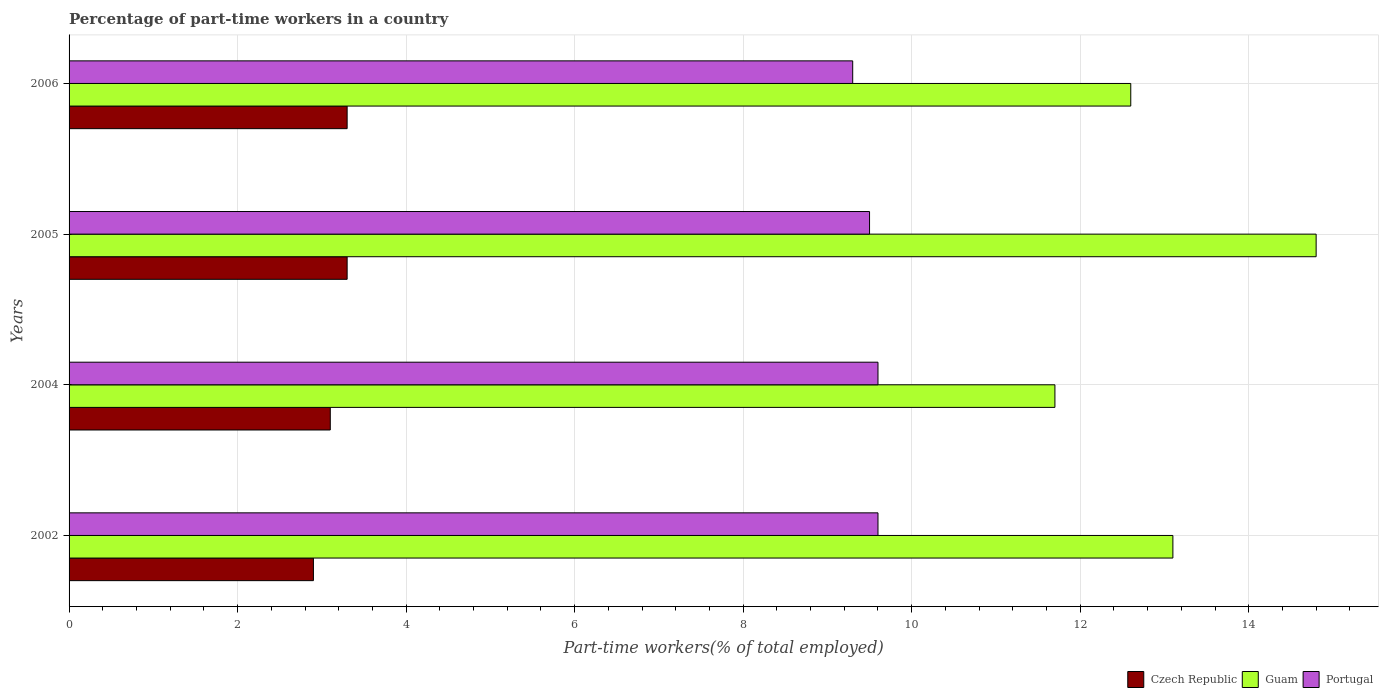How many different coloured bars are there?
Your answer should be very brief. 3. Are the number of bars per tick equal to the number of legend labels?
Give a very brief answer. Yes. In how many cases, is the number of bars for a given year not equal to the number of legend labels?
Your response must be concise. 0. What is the percentage of part-time workers in Portugal in 2002?
Keep it short and to the point. 9.6. Across all years, what is the maximum percentage of part-time workers in Portugal?
Offer a terse response. 9.6. Across all years, what is the minimum percentage of part-time workers in Czech Republic?
Your answer should be very brief. 2.9. In which year was the percentage of part-time workers in Czech Republic maximum?
Your answer should be compact. 2005. In which year was the percentage of part-time workers in Guam minimum?
Provide a short and direct response. 2004. What is the total percentage of part-time workers in Portugal in the graph?
Keep it short and to the point. 38. What is the difference between the percentage of part-time workers in Guam in 2002 and that in 2006?
Your answer should be compact. 0.5. What is the difference between the percentage of part-time workers in Portugal in 2004 and the percentage of part-time workers in Guam in 2006?
Provide a short and direct response. -3. What is the average percentage of part-time workers in Czech Republic per year?
Keep it short and to the point. 3.15. In the year 2004, what is the difference between the percentage of part-time workers in Czech Republic and percentage of part-time workers in Guam?
Ensure brevity in your answer.  -8.6. What is the ratio of the percentage of part-time workers in Guam in 2004 to that in 2005?
Make the answer very short. 0.79. Is the difference between the percentage of part-time workers in Czech Republic in 2002 and 2006 greater than the difference between the percentage of part-time workers in Guam in 2002 and 2006?
Ensure brevity in your answer.  No. What is the difference between the highest and the second highest percentage of part-time workers in Portugal?
Your answer should be compact. 0. What is the difference between the highest and the lowest percentage of part-time workers in Czech Republic?
Offer a terse response. 0.4. What does the 1st bar from the top in 2005 represents?
Make the answer very short. Portugal. Is it the case that in every year, the sum of the percentage of part-time workers in Portugal and percentage of part-time workers in Guam is greater than the percentage of part-time workers in Czech Republic?
Keep it short and to the point. Yes. Are all the bars in the graph horizontal?
Your answer should be very brief. Yes. Does the graph contain any zero values?
Ensure brevity in your answer.  No. How are the legend labels stacked?
Provide a short and direct response. Horizontal. What is the title of the graph?
Offer a terse response. Percentage of part-time workers in a country. What is the label or title of the X-axis?
Your response must be concise. Part-time workers(% of total employed). What is the label or title of the Y-axis?
Provide a succinct answer. Years. What is the Part-time workers(% of total employed) of Czech Republic in 2002?
Give a very brief answer. 2.9. What is the Part-time workers(% of total employed) of Guam in 2002?
Provide a succinct answer. 13.1. What is the Part-time workers(% of total employed) of Portugal in 2002?
Provide a short and direct response. 9.6. What is the Part-time workers(% of total employed) of Czech Republic in 2004?
Your response must be concise. 3.1. What is the Part-time workers(% of total employed) in Guam in 2004?
Your answer should be compact. 11.7. What is the Part-time workers(% of total employed) in Portugal in 2004?
Your answer should be compact. 9.6. What is the Part-time workers(% of total employed) of Czech Republic in 2005?
Ensure brevity in your answer.  3.3. What is the Part-time workers(% of total employed) in Guam in 2005?
Provide a short and direct response. 14.8. What is the Part-time workers(% of total employed) of Portugal in 2005?
Your answer should be very brief. 9.5. What is the Part-time workers(% of total employed) in Czech Republic in 2006?
Ensure brevity in your answer.  3.3. What is the Part-time workers(% of total employed) in Guam in 2006?
Your answer should be very brief. 12.6. What is the Part-time workers(% of total employed) in Portugal in 2006?
Give a very brief answer. 9.3. Across all years, what is the maximum Part-time workers(% of total employed) of Czech Republic?
Ensure brevity in your answer.  3.3. Across all years, what is the maximum Part-time workers(% of total employed) in Guam?
Offer a terse response. 14.8. Across all years, what is the maximum Part-time workers(% of total employed) in Portugal?
Keep it short and to the point. 9.6. Across all years, what is the minimum Part-time workers(% of total employed) of Czech Republic?
Offer a terse response. 2.9. Across all years, what is the minimum Part-time workers(% of total employed) in Guam?
Your answer should be compact. 11.7. Across all years, what is the minimum Part-time workers(% of total employed) in Portugal?
Your answer should be compact. 9.3. What is the total Part-time workers(% of total employed) of Czech Republic in the graph?
Make the answer very short. 12.6. What is the total Part-time workers(% of total employed) in Guam in the graph?
Your response must be concise. 52.2. What is the total Part-time workers(% of total employed) of Portugal in the graph?
Keep it short and to the point. 38. What is the difference between the Part-time workers(% of total employed) in Guam in 2002 and that in 2004?
Keep it short and to the point. 1.4. What is the difference between the Part-time workers(% of total employed) in Czech Republic in 2002 and that in 2005?
Keep it short and to the point. -0.4. What is the difference between the Part-time workers(% of total employed) in Czech Republic in 2002 and that in 2006?
Ensure brevity in your answer.  -0.4. What is the difference between the Part-time workers(% of total employed) of Guam in 2002 and that in 2006?
Provide a succinct answer. 0.5. What is the difference between the Part-time workers(% of total employed) of Czech Republic in 2004 and that in 2005?
Your answer should be compact. -0.2. What is the difference between the Part-time workers(% of total employed) of Guam in 2004 and that in 2005?
Provide a short and direct response. -3.1. What is the difference between the Part-time workers(% of total employed) of Portugal in 2004 and that in 2005?
Your response must be concise. 0.1. What is the difference between the Part-time workers(% of total employed) of Portugal in 2004 and that in 2006?
Your answer should be very brief. 0.3. What is the difference between the Part-time workers(% of total employed) in Czech Republic in 2005 and that in 2006?
Make the answer very short. 0. What is the difference between the Part-time workers(% of total employed) in Guam in 2005 and that in 2006?
Ensure brevity in your answer.  2.2. What is the difference between the Part-time workers(% of total employed) of Czech Republic in 2002 and the Part-time workers(% of total employed) of Guam in 2004?
Your response must be concise. -8.8. What is the difference between the Part-time workers(% of total employed) in Czech Republic in 2002 and the Part-time workers(% of total employed) in Portugal in 2004?
Offer a very short reply. -6.7. What is the difference between the Part-time workers(% of total employed) in Czech Republic in 2002 and the Part-time workers(% of total employed) in Guam in 2005?
Ensure brevity in your answer.  -11.9. What is the difference between the Part-time workers(% of total employed) of Guam in 2002 and the Part-time workers(% of total employed) of Portugal in 2005?
Your response must be concise. 3.6. What is the difference between the Part-time workers(% of total employed) in Czech Republic in 2002 and the Part-time workers(% of total employed) in Guam in 2006?
Provide a short and direct response. -9.7. What is the difference between the Part-time workers(% of total employed) of Czech Republic in 2004 and the Part-time workers(% of total employed) of Portugal in 2005?
Offer a terse response. -6.4. What is the difference between the Part-time workers(% of total employed) of Czech Republic in 2004 and the Part-time workers(% of total employed) of Guam in 2006?
Your answer should be very brief. -9.5. What is the difference between the Part-time workers(% of total employed) of Czech Republic in 2004 and the Part-time workers(% of total employed) of Portugal in 2006?
Your answer should be compact. -6.2. What is the difference between the Part-time workers(% of total employed) of Guam in 2004 and the Part-time workers(% of total employed) of Portugal in 2006?
Your answer should be very brief. 2.4. What is the difference between the Part-time workers(% of total employed) in Czech Republic in 2005 and the Part-time workers(% of total employed) in Guam in 2006?
Your answer should be compact. -9.3. What is the difference between the Part-time workers(% of total employed) of Czech Republic in 2005 and the Part-time workers(% of total employed) of Portugal in 2006?
Give a very brief answer. -6. What is the average Part-time workers(% of total employed) of Czech Republic per year?
Your answer should be very brief. 3.15. What is the average Part-time workers(% of total employed) in Guam per year?
Make the answer very short. 13.05. In the year 2002, what is the difference between the Part-time workers(% of total employed) in Czech Republic and Part-time workers(% of total employed) in Guam?
Your answer should be compact. -10.2. In the year 2002, what is the difference between the Part-time workers(% of total employed) in Czech Republic and Part-time workers(% of total employed) in Portugal?
Offer a very short reply. -6.7. In the year 2002, what is the difference between the Part-time workers(% of total employed) in Guam and Part-time workers(% of total employed) in Portugal?
Make the answer very short. 3.5. In the year 2004, what is the difference between the Part-time workers(% of total employed) of Czech Republic and Part-time workers(% of total employed) of Portugal?
Offer a very short reply. -6.5. In the year 2005, what is the difference between the Part-time workers(% of total employed) in Czech Republic and Part-time workers(% of total employed) in Guam?
Offer a terse response. -11.5. In the year 2005, what is the difference between the Part-time workers(% of total employed) in Guam and Part-time workers(% of total employed) in Portugal?
Provide a succinct answer. 5.3. In the year 2006, what is the difference between the Part-time workers(% of total employed) of Guam and Part-time workers(% of total employed) of Portugal?
Your answer should be very brief. 3.3. What is the ratio of the Part-time workers(% of total employed) of Czech Republic in 2002 to that in 2004?
Your answer should be compact. 0.94. What is the ratio of the Part-time workers(% of total employed) in Guam in 2002 to that in 2004?
Make the answer very short. 1.12. What is the ratio of the Part-time workers(% of total employed) in Czech Republic in 2002 to that in 2005?
Make the answer very short. 0.88. What is the ratio of the Part-time workers(% of total employed) of Guam in 2002 to that in 2005?
Your response must be concise. 0.89. What is the ratio of the Part-time workers(% of total employed) in Portugal in 2002 to that in 2005?
Give a very brief answer. 1.01. What is the ratio of the Part-time workers(% of total employed) of Czech Republic in 2002 to that in 2006?
Your answer should be compact. 0.88. What is the ratio of the Part-time workers(% of total employed) of Guam in 2002 to that in 2006?
Provide a succinct answer. 1.04. What is the ratio of the Part-time workers(% of total employed) in Portugal in 2002 to that in 2006?
Your response must be concise. 1.03. What is the ratio of the Part-time workers(% of total employed) of Czech Republic in 2004 to that in 2005?
Provide a short and direct response. 0.94. What is the ratio of the Part-time workers(% of total employed) in Guam in 2004 to that in 2005?
Make the answer very short. 0.79. What is the ratio of the Part-time workers(% of total employed) in Portugal in 2004 to that in 2005?
Your response must be concise. 1.01. What is the ratio of the Part-time workers(% of total employed) in Czech Republic in 2004 to that in 2006?
Give a very brief answer. 0.94. What is the ratio of the Part-time workers(% of total employed) of Portugal in 2004 to that in 2006?
Provide a succinct answer. 1.03. What is the ratio of the Part-time workers(% of total employed) of Guam in 2005 to that in 2006?
Give a very brief answer. 1.17. What is the ratio of the Part-time workers(% of total employed) of Portugal in 2005 to that in 2006?
Provide a succinct answer. 1.02. What is the difference between the highest and the lowest Part-time workers(% of total employed) of Portugal?
Your response must be concise. 0.3. 